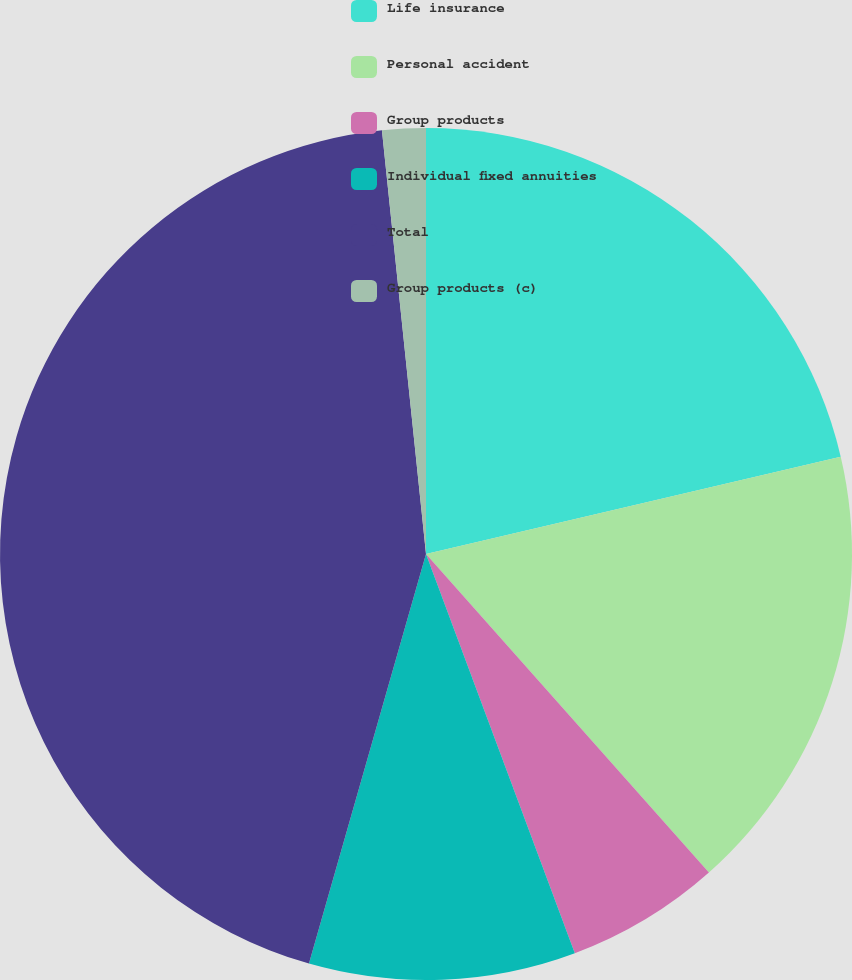Convert chart to OTSL. <chart><loc_0><loc_0><loc_500><loc_500><pie_chart><fcel>Life insurance<fcel>Personal accident<fcel>Group products<fcel>Individual fixed annuities<fcel>Total<fcel>Group products (c)<nl><fcel>21.33%<fcel>17.11%<fcel>5.88%<fcel>10.11%<fcel>43.92%<fcel>1.65%<nl></chart> 